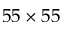<formula> <loc_0><loc_0><loc_500><loc_500>5 5 \times 5 5</formula> 